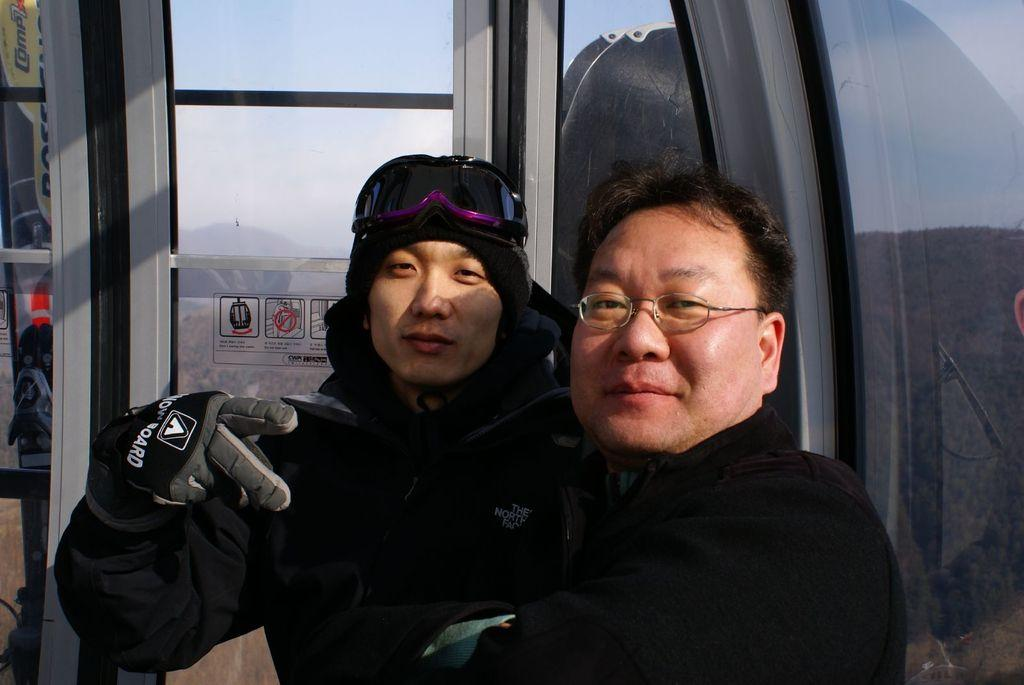How many people are in the image? There are two men in the image. What are the men wearing? The men are wearing black jackets. What expression do the men have? The men are smiling. What are the men doing in the image? The men are posing for the camera. What can be seen in the background of the image? There is a lift glass door in the background of the image. What is the tendency of the banana in the image? There is no banana present in the image, so it is not possible to determine its tendency. How are the men using the banana in the image? There is no banana present in the image, so it cannot be used by the men. 